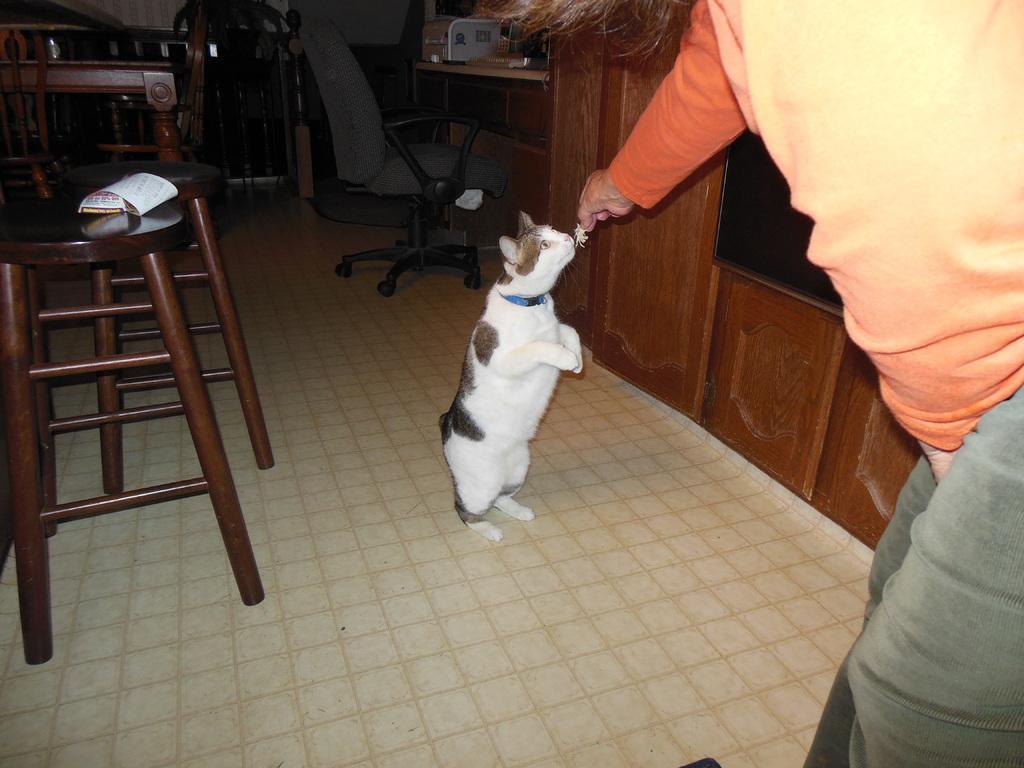Can you describe this image briefly? In the given image we can see a person and a cat. There is a stool, chair and a table in the room. 